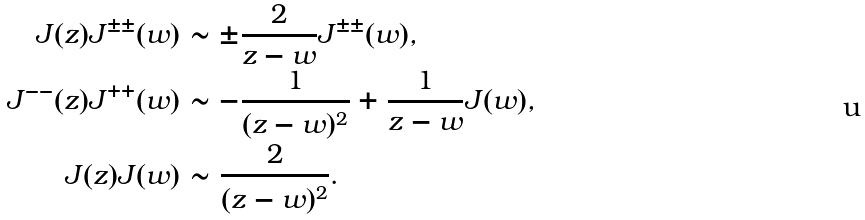<formula> <loc_0><loc_0><loc_500><loc_500>J ( z ) J ^ { \pm \pm } ( w ) & \sim \pm \frac { 2 } { z - w } J ^ { \pm \pm } ( w ) , \\ J ^ { - - } ( z ) J ^ { + + } ( w ) & \sim - \frac { 1 } { ( z - w ) ^ { 2 } } + \frac { 1 } { z - w } J ( w ) , \\ J ( z ) J ( w ) & \sim \frac { 2 } { ( z - w ) ^ { 2 } } .</formula> 